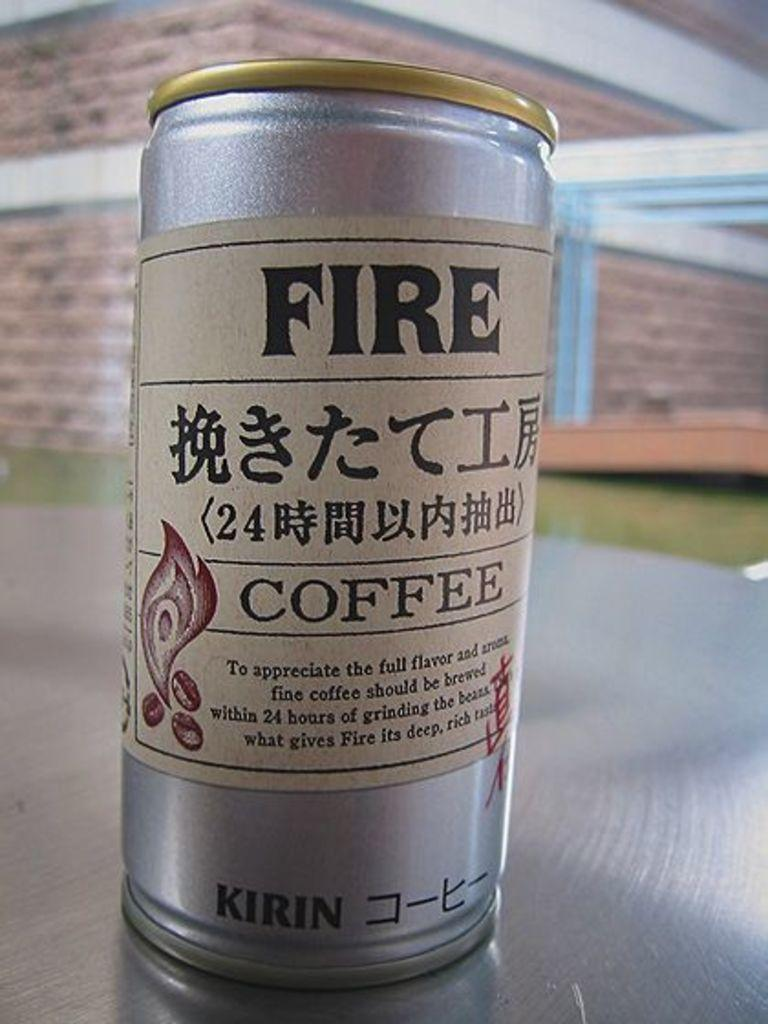<image>
Summarize the visual content of the image. silver can that has fire coffee on it along with chinese symbols 